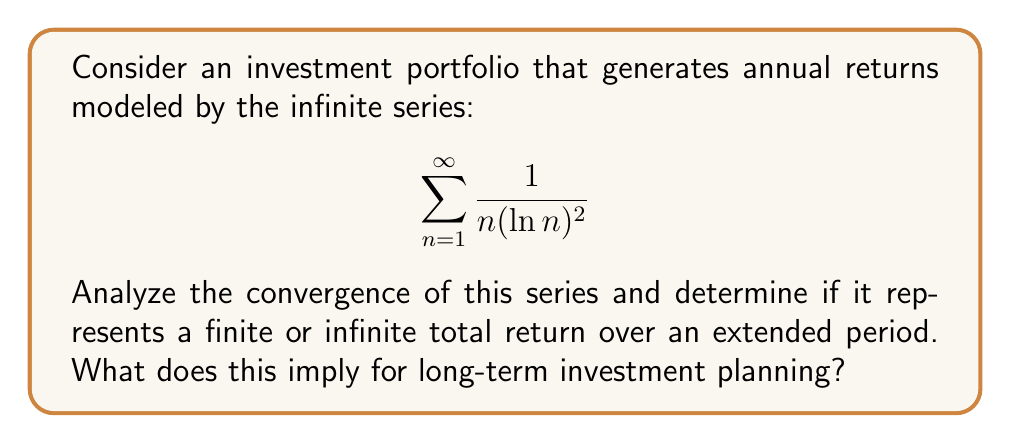Solve this math problem. To analyze the convergence of this series, we can use the integral test. Let's define:

$$ f(x) = \frac{1}{x(\ln x)^2} $$

1) First, we need to check if $f(x)$ is continuous, positive, and decreasing for $x \geq 2$:
   - $f(x)$ is continuous for $x > 1$
   - $f(x)$ is positive for $x > 1$
   - $f'(x) = -\frac{(\ln x)^2 + 2\ln x}{x^2(\ln x)^4} < 0$ for $x > 1$, so $f(x)$ is decreasing

2) Now, we can apply the integral test:

   $$ \int_2^{\infty} \frac{1}{x(\ln x)^2} dx $$

3) Let $u = \ln x$, then $du = \frac{1}{x}dx$:

   $$ \int_{\ln 2}^{\infty} \frac{1}{u^2} du $$

4) Evaluate the integral:

   $$ \left[ -\frac{1}{u} \right]_{\ln 2}^{\infty} = 0 - \left(-\frac{1}{\ln 2}\right) = \frac{1}{\ln 2} $$

5) Since the integral converges to a finite value, the original series also converges.

This implies that the total return over an infinite period is finite. For long-term investment planning, this suggests that while the portfolio will continue to generate positive returns each year, the cumulative return will approach a limit. This could indicate diminishing returns over time, which might influence decisions about portfolio rebalancing or seeking alternative investment strategies to maintain growth.
Answer: The series converges, representing a finite total return over an extended period. The sum approaches $\frac{1}{\ln 2} + C$, where $C$ is a constant accounting for the difference between the series and the integral from 2 to infinity. 